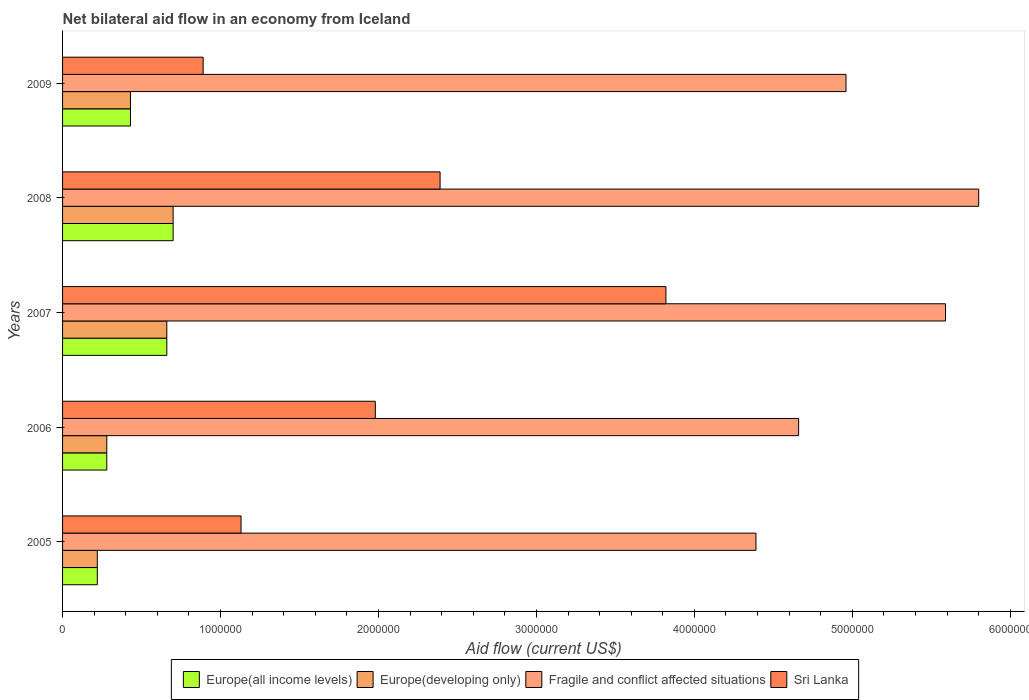How many different coloured bars are there?
Your answer should be compact. 4. How many groups of bars are there?
Offer a terse response. 5. Are the number of bars on each tick of the Y-axis equal?
Offer a terse response. Yes. How many bars are there on the 2nd tick from the top?
Your answer should be very brief. 4. What is the net bilateral aid flow in Europe(all income levels) in 2007?
Provide a short and direct response. 6.60e+05. Across all years, what is the maximum net bilateral aid flow in Fragile and conflict affected situations?
Keep it short and to the point. 5.80e+06. Across all years, what is the minimum net bilateral aid flow in Fragile and conflict affected situations?
Your answer should be very brief. 4.39e+06. What is the total net bilateral aid flow in Europe(all income levels) in the graph?
Keep it short and to the point. 2.29e+06. What is the difference between the net bilateral aid flow in Europe(developing only) in 2009 and the net bilateral aid flow in Fragile and conflict affected situations in 2007?
Provide a short and direct response. -5.16e+06. What is the average net bilateral aid flow in Sri Lanka per year?
Offer a very short reply. 2.04e+06. In the year 2005, what is the difference between the net bilateral aid flow in Sri Lanka and net bilateral aid flow in Europe(developing only)?
Provide a succinct answer. 9.10e+05. In how many years, is the net bilateral aid flow in Europe(all income levels) greater than 2800000 US$?
Provide a succinct answer. 0. What is the ratio of the net bilateral aid flow in Europe(all income levels) in 2005 to that in 2008?
Provide a short and direct response. 0.31. Is the net bilateral aid flow in Europe(developing only) in 2006 less than that in 2008?
Provide a short and direct response. Yes. Is the difference between the net bilateral aid flow in Sri Lanka in 2005 and 2008 greater than the difference between the net bilateral aid flow in Europe(developing only) in 2005 and 2008?
Offer a very short reply. No. What is the difference between the highest and the lowest net bilateral aid flow in Europe(all income levels)?
Give a very brief answer. 4.80e+05. In how many years, is the net bilateral aid flow in Europe(developing only) greater than the average net bilateral aid flow in Europe(developing only) taken over all years?
Your answer should be very brief. 2. Is the sum of the net bilateral aid flow in Europe(developing only) in 2008 and 2009 greater than the maximum net bilateral aid flow in Europe(all income levels) across all years?
Offer a terse response. Yes. What does the 1st bar from the top in 2008 represents?
Make the answer very short. Sri Lanka. What does the 4th bar from the bottom in 2008 represents?
Your answer should be compact. Sri Lanka. Is it the case that in every year, the sum of the net bilateral aid flow in Europe(all income levels) and net bilateral aid flow in Europe(developing only) is greater than the net bilateral aid flow in Fragile and conflict affected situations?
Offer a terse response. No. How many bars are there?
Offer a very short reply. 20. Are all the bars in the graph horizontal?
Give a very brief answer. Yes. How many years are there in the graph?
Offer a terse response. 5. What is the difference between two consecutive major ticks on the X-axis?
Offer a terse response. 1.00e+06. How many legend labels are there?
Offer a very short reply. 4. What is the title of the graph?
Offer a very short reply. Net bilateral aid flow in an economy from Iceland. Does "Libya" appear as one of the legend labels in the graph?
Give a very brief answer. No. What is the label or title of the Y-axis?
Offer a very short reply. Years. What is the Aid flow (current US$) in Europe(developing only) in 2005?
Make the answer very short. 2.20e+05. What is the Aid flow (current US$) in Fragile and conflict affected situations in 2005?
Ensure brevity in your answer.  4.39e+06. What is the Aid flow (current US$) in Sri Lanka in 2005?
Your response must be concise. 1.13e+06. What is the Aid flow (current US$) in Europe(all income levels) in 2006?
Your answer should be compact. 2.80e+05. What is the Aid flow (current US$) in Europe(developing only) in 2006?
Give a very brief answer. 2.80e+05. What is the Aid flow (current US$) in Fragile and conflict affected situations in 2006?
Provide a succinct answer. 4.66e+06. What is the Aid flow (current US$) in Sri Lanka in 2006?
Offer a very short reply. 1.98e+06. What is the Aid flow (current US$) in Europe(all income levels) in 2007?
Offer a terse response. 6.60e+05. What is the Aid flow (current US$) of Fragile and conflict affected situations in 2007?
Make the answer very short. 5.59e+06. What is the Aid flow (current US$) of Sri Lanka in 2007?
Give a very brief answer. 3.82e+06. What is the Aid flow (current US$) in Fragile and conflict affected situations in 2008?
Offer a terse response. 5.80e+06. What is the Aid flow (current US$) in Sri Lanka in 2008?
Your response must be concise. 2.39e+06. What is the Aid flow (current US$) of Europe(developing only) in 2009?
Give a very brief answer. 4.30e+05. What is the Aid flow (current US$) of Fragile and conflict affected situations in 2009?
Give a very brief answer. 4.96e+06. What is the Aid flow (current US$) of Sri Lanka in 2009?
Give a very brief answer. 8.90e+05. Across all years, what is the maximum Aid flow (current US$) of Fragile and conflict affected situations?
Your answer should be compact. 5.80e+06. Across all years, what is the maximum Aid flow (current US$) in Sri Lanka?
Your answer should be compact. 3.82e+06. Across all years, what is the minimum Aid flow (current US$) in Europe(all income levels)?
Offer a very short reply. 2.20e+05. Across all years, what is the minimum Aid flow (current US$) of Europe(developing only)?
Give a very brief answer. 2.20e+05. Across all years, what is the minimum Aid flow (current US$) in Fragile and conflict affected situations?
Offer a very short reply. 4.39e+06. Across all years, what is the minimum Aid flow (current US$) in Sri Lanka?
Ensure brevity in your answer.  8.90e+05. What is the total Aid flow (current US$) of Europe(all income levels) in the graph?
Ensure brevity in your answer.  2.29e+06. What is the total Aid flow (current US$) of Europe(developing only) in the graph?
Your response must be concise. 2.29e+06. What is the total Aid flow (current US$) in Fragile and conflict affected situations in the graph?
Offer a terse response. 2.54e+07. What is the total Aid flow (current US$) of Sri Lanka in the graph?
Provide a short and direct response. 1.02e+07. What is the difference between the Aid flow (current US$) in Sri Lanka in 2005 and that in 2006?
Give a very brief answer. -8.50e+05. What is the difference between the Aid flow (current US$) of Europe(all income levels) in 2005 and that in 2007?
Make the answer very short. -4.40e+05. What is the difference between the Aid flow (current US$) of Europe(developing only) in 2005 and that in 2007?
Your answer should be very brief. -4.40e+05. What is the difference between the Aid flow (current US$) of Fragile and conflict affected situations in 2005 and that in 2007?
Ensure brevity in your answer.  -1.20e+06. What is the difference between the Aid flow (current US$) of Sri Lanka in 2005 and that in 2007?
Offer a very short reply. -2.69e+06. What is the difference between the Aid flow (current US$) of Europe(all income levels) in 2005 and that in 2008?
Keep it short and to the point. -4.80e+05. What is the difference between the Aid flow (current US$) in Europe(developing only) in 2005 and that in 2008?
Offer a very short reply. -4.80e+05. What is the difference between the Aid flow (current US$) in Fragile and conflict affected situations in 2005 and that in 2008?
Ensure brevity in your answer.  -1.41e+06. What is the difference between the Aid flow (current US$) of Sri Lanka in 2005 and that in 2008?
Your answer should be very brief. -1.26e+06. What is the difference between the Aid flow (current US$) of Fragile and conflict affected situations in 2005 and that in 2009?
Offer a terse response. -5.70e+05. What is the difference between the Aid flow (current US$) in Sri Lanka in 2005 and that in 2009?
Offer a very short reply. 2.40e+05. What is the difference between the Aid flow (current US$) in Europe(all income levels) in 2006 and that in 2007?
Your response must be concise. -3.80e+05. What is the difference between the Aid flow (current US$) of Europe(developing only) in 2006 and that in 2007?
Offer a very short reply. -3.80e+05. What is the difference between the Aid flow (current US$) in Fragile and conflict affected situations in 2006 and that in 2007?
Ensure brevity in your answer.  -9.30e+05. What is the difference between the Aid flow (current US$) of Sri Lanka in 2006 and that in 2007?
Make the answer very short. -1.84e+06. What is the difference between the Aid flow (current US$) in Europe(all income levels) in 2006 and that in 2008?
Provide a short and direct response. -4.20e+05. What is the difference between the Aid flow (current US$) of Europe(developing only) in 2006 and that in 2008?
Ensure brevity in your answer.  -4.20e+05. What is the difference between the Aid flow (current US$) of Fragile and conflict affected situations in 2006 and that in 2008?
Your answer should be very brief. -1.14e+06. What is the difference between the Aid flow (current US$) of Sri Lanka in 2006 and that in 2008?
Offer a very short reply. -4.10e+05. What is the difference between the Aid flow (current US$) of Europe(developing only) in 2006 and that in 2009?
Your answer should be very brief. -1.50e+05. What is the difference between the Aid flow (current US$) of Sri Lanka in 2006 and that in 2009?
Make the answer very short. 1.09e+06. What is the difference between the Aid flow (current US$) in Europe(all income levels) in 2007 and that in 2008?
Provide a succinct answer. -4.00e+04. What is the difference between the Aid flow (current US$) of Europe(developing only) in 2007 and that in 2008?
Your answer should be very brief. -4.00e+04. What is the difference between the Aid flow (current US$) of Fragile and conflict affected situations in 2007 and that in 2008?
Provide a succinct answer. -2.10e+05. What is the difference between the Aid flow (current US$) in Sri Lanka in 2007 and that in 2008?
Offer a very short reply. 1.43e+06. What is the difference between the Aid flow (current US$) of Europe(all income levels) in 2007 and that in 2009?
Your answer should be compact. 2.30e+05. What is the difference between the Aid flow (current US$) in Fragile and conflict affected situations in 2007 and that in 2009?
Give a very brief answer. 6.30e+05. What is the difference between the Aid flow (current US$) of Sri Lanka in 2007 and that in 2009?
Provide a short and direct response. 2.93e+06. What is the difference between the Aid flow (current US$) of Europe(all income levels) in 2008 and that in 2009?
Offer a very short reply. 2.70e+05. What is the difference between the Aid flow (current US$) of Europe(developing only) in 2008 and that in 2009?
Your response must be concise. 2.70e+05. What is the difference between the Aid flow (current US$) in Fragile and conflict affected situations in 2008 and that in 2009?
Make the answer very short. 8.40e+05. What is the difference between the Aid flow (current US$) of Sri Lanka in 2008 and that in 2009?
Your response must be concise. 1.50e+06. What is the difference between the Aid flow (current US$) in Europe(all income levels) in 2005 and the Aid flow (current US$) in Fragile and conflict affected situations in 2006?
Ensure brevity in your answer.  -4.44e+06. What is the difference between the Aid flow (current US$) of Europe(all income levels) in 2005 and the Aid flow (current US$) of Sri Lanka in 2006?
Give a very brief answer. -1.76e+06. What is the difference between the Aid flow (current US$) in Europe(developing only) in 2005 and the Aid flow (current US$) in Fragile and conflict affected situations in 2006?
Offer a terse response. -4.44e+06. What is the difference between the Aid flow (current US$) of Europe(developing only) in 2005 and the Aid flow (current US$) of Sri Lanka in 2006?
Keep it short and to the point. -1.76e+06. What is the difference between the Aid flow (current US$) of Fragile and conflict affected situations in 2005 and the Aid flow (current US$) of Sri Lanka in 2006?
Ensure brevity in your answer.  2.41e+06. What is the difference between the Aid flow (current US$) of Europe(all income levels) in 2005 and the Aid flow (current US$) of Europe(developing only) in 2007?
Make the answer very short. -4.40e+05. What is the difference between the Aid flow (current US$) of Europe(all income levels) in 2005 and the Aid flow (current US$) of Fragile and conflict affected situations in 2007?
Your answer should be very brief. -5.37e+06. What is the difference between the Aid flow (current US$) in Europe(all income levels) in 2005 and the Aid flow (current US$) in Sri Lanka in 2007?
Offer a terse response. -3.60e+06. What is the difference between the Aid flow (current US$) of Europe(developing only) in 2005 and the Aid flow (current US$) of Fragile and conflict affected situations in 2007?
Give a very brief answer. -5.37e+06. What is the difference between the Aid flow (current US$) of Europe(developing only) in 2005 and the Aid flow (current US$) of Sri Lanka in 2007?
Keep it short and to the point. -3.60e+06. What is the difference between the Aid flow (current US$) in Fragile and conflict affected situations in 2005 and the Aid flow (current US$) in Sri Lanka in 2007?
Provide a short and direct response. 5.70e+05. What is the difference between the Aid flow (current US$) in Europe(all income levels) in 2005 and the Aid flow (current US$) in Europe(developing only) in 2008?
Offer a very short reply. -4.80e+05. What is the difference between the Aid flow (current US$) of Europe(all income levels) in 2005 and the Aid flow (current US$) of Fragile and conflict affected situations in 2008?
Keep it short and to the point. -5.58e+06. What is the difference between the Aid flow (current US$) in Europe(all income levels) in 2005 and the Aid flow (current US$) in Sri Lanka in 2008?
Keep it short and to the point. -2.17e+06. What is the difference between the Aid flow (current US$) of Europe(developing only) in 2005 and the Aid flow (current US$) of Fragile and conflict affected situations in 2008?
Your answer should be compact. -5.58e+06. What is the difference between the Aid flow (current US$) in Europe(developing only) in 2005 and the Aid flow (current US$) in Sri Lanka in 2008?
Offer a very short reply. -2.17e+06. What is the difference between the Aid flow (current US$) in Fragile and conflict affected situations in 2005 and the Aid flow (current US$) in Sri Lanka in 2008?
Give a very brief answer. 2.00e+06. What is the difference between the Aid flow (current US$) of Europe(all income levels) in 2005 and the Aid flow (current US$) of Fragile and conflict affected situations in 2009?
Offer a terse response. -4.74e+06. What is the difference between the Aid flow (current US$) of Europe(all income levels) in 2005 and the Aid flow (current US$) of Sri Lanka in 2009?
Keep it short and to the point. -6.70e+05. What is the difference between the Aid flow (current US$) of Europe(developing only) in 2005 and the Aid flow (current US$) of Fragile and conflict affected situations in 2009?
Give a very brief answer. -4.74e+06. What is the difference between the Aid flow (current US$) of Europe(developing only) in 2005 and the Aid flow (current US$) of Sri Lanka in 2009?
Your answer should be very brief. -6.70e+05. What is the difference between the Aid flow (current US$) in Fragile and conflict affected situations in 2005 and the Aid flow (current US$) in Sri Lanka in 2009?
Keep it short and to the point. 3.50e+06. What is the difference between the Aid flow (current US$) in Europe(all income levels) in 2006 and the Aid flow (current US$) in Europe(developing only) in 2007?
Ensure brevity in your answer.  -3.80e+05. What is the difference between the Aid flow (current US$) in Europe(all income levels) in 2006 and the Aid flow (current US$) in Fragile and conflict affected situations in 2007?
Offer a very short reply. -5.31e+06. What is the difference between the Aid flow (current US$) in Europe(all income levels) in 2006 and the Aid flow (current US$) in Sri Lanka in 2007?
Your answer should be compact. -3.54e+06. What is the difference between the Aid flow (current US$) of Europe(developing only) in 2006 and the Aid flow (current US$) of Fragile and conflict affected situations in 2007?
Give a very brief answer. -5.31e+06. What is the difference between the Aid flow (current US$) of Europe(developing only) in 2006 and the Aid flow (current US$) of Sri Lanka in 2007?
Provide a short and direct response. -3.54e+06. What is the difference between the Aid flow (current US$) of Fragile and conflict affected situations in 2006 and the Aid flow (current US$) of Sri Lanka in 2007?
Keep it short and to the point. 8.40e+05. What is the difference between the Aid flow (current US$) in Europe(all income levels) in 2006 and the Aid flow (current US$) in Europe(developing only) in 2008?
Your answer should be very brief. -4.20e+05. What is the difference between the Aid flow (current US$) in Europe(all income levels) in 2006 and the Aid flow (current US$) in Fragile and conflict affected situations in 2008?
Your answer should be compact. -5.52e+06. What is the difference between the Aid flow (current US$) in Europe(all income levels) in 2006 and the Aid flow (current US$) in Sri Lanka in 2008?
Make the answer very short. -2.11e+06. What is the difference between the Aid flow (current US$) in Europe(developing only) in 2006 and the Aid flow (current US$) in Fragile and conflict affected situations in 2008?
Give a very brief answer. -5.52e+06. What is the difference between the Aid flow (current US$) of Europe(developing only) in 2006 and the Aid flow (current US$) of Sri Lanka in 2008?
Give a very brief answer. -2.11e+06. What is the difference between the Aid flow (current US$) of Fragile and conflict affected situations in 2006 and the Aid flow (current US$) of Sri Lanka in 2008?
Make the answer very short. 2.27e+06. What is the difference between the Aid flow (current US$) in Europe(all income levels) in 2006 and the Aid flow (current US$) in Fragile and conflict affected situations in 2009?
Provide a short and direct response. -4.68e+06. What is the difference between the Aid flow (current US$) of Europe(all income levels) in 2006 and the Aid flow (current US$) of Sri Lanka in 2009?
Your answer should be very brief. -6.10e+05. What is the difference between the Aid flow (current US$) in Europe(developing only) in 2006 and the Aid flow (current US$) in Fragile and conflict affected situations in 2009?
Give a very brief answer. -4.68e+06. What is the difference between the Aid flow (current US$) in Europe(developing only) in 2006 and the Aid flow (current US$) in Sri Lanka in 2009?
Make the answer very short. -6.10e+05. What is the difference between the Aid flow (current US$) of Fragile and conflict affected situations in 2006 and the Aid flow (current US$) of Sri Lanka in 2009?
Ensure brevity in your answer.  3.77e+06. What is the difference between the Aid flow (current US$) of Europe(all income levels) in 2007 and the Aid flow (current US$) of Europe(developing only) in 2008?
Offer a very short reply. -4.00e+04. What is the difference between the Aid flow (current US$) in Europe(all income levels) in 2007 and the Aid flow (current US$) in Fragile and conflict affected situations in 2008?
Your answer should be compact. -5.14e+06. What is the difference between the Aid flow (current US$) of Europe(all income levels) in 2007 and the Aid flow (current US$) of Sri Lanka in 2008?
Make the answer very short. -1.73e+06. What is the difference between the Aid flow (current US$) of Europe(developing only) in 2007 and the Aid flow (current US$) of Fragile and conflict affected situations in 2008?
Offer a terse response. -5.14e+06. What is the difference between the Aid flow (current US$) in Europe(developing only) in 2007 and the Aid flow (current US$) in Sri Lanka in 2008?
Your answer should be compact. -1.73e+06. What is the difference between the Aid flow (current US$) in Fragile and conflict affected situations in 2007 and the Aid flow (current US$) in Sri Lanka in 2008?
Make the answer very short. 3.20e+06. What is the difference between the Aid flow (current US$) of Europe(all income levels) in 2007 and the Aid flow (current US$) of Europe(developing only) in 2009?
Ensure brevity in your answer.  2.30e+05. What is the difference between the Aid flow (current US$) of Europe(all income levels) in 2007 and the Aid flow (current US$) of Fragile and conflict affected situations in 2009?
Your response must be concise. -4.30e+06. What is the difference between the Aid flow (current US$) in Europe(developing only) in 2007 and the Aid flow (current US$) in Fragile and conflict affected situations in 2009?
Provide a short and direct response. -4.30e+06. What is the difference between the Aid flow (current US$) in Fragile and conflict affected situations in 2007 and the Aid flow (current US$) in Sri Lanka in 2009?
Your answer should be compact. 4.70e+06. What is the difference between the Aid flow (current US$) of Europe(all income levels) in 2008 and the Aid flow (current US$) of Fragile and conflict affected situations in 2009?
Provide a succinct answer. -4.26e+06. What is the difference between the Aid flow (current US$) of Europe(all income levels) in 2008 and the Aid flow (current US$) of Sri Lanka in 2009?
Offer a very short reply. -1.90e+05. What is the difference between the Aid flow (current US$) in Europe(developing only) in 2008 and the Aid flow (current US$) in Fragile and conflict affected situations in 2009?
Your answer should be very brief. -4.26e+06. What is the difference between the Aid flow (current US$) of Fragile and conflict affected situations in 2008 and the Aid flow (current US$) of Sri Lanka in 2009?
Provide a short and direct response. 4.91e+06. What is the average Aid flow (current US$) in Europe(all income levels) per year?
Ensure brevity in your answer.  4.58e+05. What is the average Aid flow (current US$) in Europe(developing only) per year?
Provide a succinct answer. 4.58e+05. What is the average Aid flow (current US$) in Fragile and conflict affected situations per year?
Ensure brevity in your answer.  5.08e+06. What is the average Aid flow (current US$) in Sri Lanka per year?
Offer a terse response. 2.04e+06. In the year 2005, what is the difference between the Aid flow (current US$) in Europe(all income levels) and Aid flow (current US$) in Fragile and conflict affected situations?
Make the answer very short. -4.17e+06. In the year 2005, what is the difference between the Aid flow (current US$) in Europe(all income levels) and Aid flow (current US$) in Sri Lanka?
Your response must be concise. -9.10e+05. In the year 2005, what is the difference between the Aid flow (current US$) in Europe(developing only) and Aid flow (current US$) in Fragile and conflict affected situations?
Make the answer very short. -4.17e+06. In the year 2005, what is the difference between the Aid flow (current US$) in Europe(developing only) and Aid flow (current US$) in Sri Lanka?
Keep it short and to the point. -9.10e+05. In the year 2005, what is the difference between the Aid flow (current US$) in Fragile and conflict affected situations and Aid flow (current US$) in Sri Lanka?
Offer a terse response. 3.26e+06. In the year 2006, what is the difference between the Aid flow (current US$) in Europe(all income levels) and Aid flow (current US$) in Europe(developing only)?
Make the answer very short. 0. In the year 2006, what is the difference between the Aid flow (current US$) in Europe(all income levels) and Aid flow (current US$) in Fragile and conflict affected situations?
Your response must be concise. -4.38e+06. In the year 2006, what is the difference between the Aid flow (current US$) of Europe(all income levels) and Aid flow (current US$) of Sri Lanka?
Keep it short and to the point. -1.70e+06. In the year 2006, what is the difference between the Aid flow (current US$) of Europe(developing only) and Aid flow (current US$) of Fragile and conflict affected situations?
Provide a succinct answer. -4.38e+06. In the year 2006, what is the difference between the Aid flow (current US$) in Europe(developing only) and Aid flow (current US$) in Sri Lanka?
Ensure brevity in your answer.  -1.70e+06. In the year 2006, what is the difference between the Aid flow (current US$) of Fragile and conflict affected situations and Aid flow (current US$) of Sri Lanka?
Keep it short and to the point. 2.68e+06. In the year 2007, what is the difference between the Aid flow (current US$) of Europe(all income levels) and Aid flow (current US$) of Fragile and conflict affected situations?
Provide a succinct answer. -4.93e+06. In the year 2007, what is the difference between the Aid flow (current US$) in Europe(all income levels) and Aid flow (current US$) in Sri Lanka?
Keep it short and to the point. -3.16e+06. In the year 2007, what is the difference between the Aid flow (current US$) in Europe(developing only) and Aid flow (current US$) in Fragile and conflict affected situations?
Make the answer very short. -4.93e+06. In the year 2007, what is the difference between the Aid flow (current US$) in Europe(developing only) and Aid flow (current US$) in Sri Lanka?
Ensure brevity in your answer.  -3.16e+06. In the year 2007, what is the difference between the Aid flow (current US$) in Fragile and conflict affected situations and Aid flow (current US$) in Sri Lanka?
Your response must be concise. 1.77e+06. In the year 2008, what is the difference between the Aid flow (current US$) in Europe(all income levels) and Aid flow (current US$) in Europe(developing only)?
Provide a short and direct response. 0. In the year 2008, what is the difference between the Aid flow (current US$) of Europe(all income levels) and Aid flow (current US$) of Fragile and conflict affected situations?
Offer a terse response. -5.10e+06. In the year 2008, what is the difference between the Aid flow (current US$) of Europe(all income levels) and Aid flow (current US$) of Sri Lanka?
Offer a terse response. -1.69e+06. In the year 2008, what is the difference between the Aid flow (current US$) of Europe(developing only) and Aid flow (current US$) of Fragile and conflict affected situations?
Offer a terse response. -5.10e+06. In the year 2008, what is the difference between the Aid flow (current US$) in Europe(developing only) and Aid flow (current US$) in Sri Lanka?
Give a very brief answer. -1.69e+06. In the year 2008, what is the difference between the Aid flow (current US$) in Fragile and conflict affected situations and Aid flow (current US$) in Sri Lanka?
Your answer should be compact. 3.41e+06. In the year 2009, what is the difference between the Aid flow (current US$) of Europe(all income levels) and Aid flow (current US$) of Fragile and conflict affected situations?
Make the answer very short. -4.53e+06. In the year 2009, what is the difference between the Aid flow (current US$) of Europe(all income levels) and Aid flow (current US$) of Sri Lanka?
Your answer should be very brief. -4.60e+05. In the year 2009, what is the difference between the Aid flow (current US$) of Europe(developing only) and Aid flow (current US$) of Fragile and conflict affected situations?
Ensure brevity in your answer.  -4.53e+06. In the year 2009, what is the difference between the Aid flow (current US$) in Europe(developing only) and Aid flow (current US$) in Sri Lanka?
Provide a succinct answer. -4.60e+05. In the year 2009, what is the difference between the Aid flow (current US$) of Fragile and conflict affected situations and Aid flow (current US$) of Sri Lanka?
Make the answer very short. 4.07e+06. What is the ratio of the Aid flow (current US$) of Europe(all income levels) in 2005 to that in 2006?
Offer a terse response. 0.79. What is the ratio of the Aid flow (current US$) of Europe(developing only) in 2005 to that in 2006?
Make the answer very short. 0.79. What is the ratio of the Aid flow (current US$) of Fragile and conflict affected situations in 2005 to that in 2006?
Your answer should be compact. 0.94. What is the ratio of the Aid flow (current US$) in Sri Lanka in 2005 to that in 2006?
Provide a succinct answer. 0.57. What is the ratio of the Aid flow (current US$) in Fragile and conflict affected situations in 2005 to that in 2007?
Provide a succinct answer. 0.79. What is the ratio of the Aid flow (current US$) of Sri Lanka in 2005 to that in 2007?
Offer a terse response. 0.3. What is the ratio of the Aid flow (current US$) in Europe(all income levels) in 2005 to that in 2008?
Give a very brief answer. 0.31. What is the ratio of the Aid flow (current US$) in Europe(developing only) in 2005 to that in 2008?
Make the answer very short. 0.31. What is the ratio of the Aid flow (current US$) in Fragile and conflict affected situations in 2005 to that in 2008?
Provide a succinct answer. 0.76. What is the ratio of the Aid flow (current US$) of Sri Lanka in 2005 to that in 2008?
Offer a very short reply. 0.47. What is the ratio of the Aid flow (current US$) of Europe(all income levels) in 2005 to that in 2009?
Provide a succinct answer. 0.51. What is the ratio of the Aid flow (current US$) of Europe(developing only) in 2005 to that in 2009?
Provide a short and direct response. 0.51. What is the ratio of the Aid flow (current US$) in Fragile and conflict affected situations in 2005 to that in 2009?
Offer a terse response. 0.89. What is the ratio of the Aid flow (current US$) in Sri Lanka in 2005 to that in 2009?
Your answer should be very brief. 1.27. What is the ratio of the Aid flow (current US$) of Europe(all income levels) in 2006 to that in 2007?
Make the answer very short. 0.42. What is the ratio of the Aid flow (current US$) of Europe(developing only) in 2006 to that in 2007?
Provide a succinct answer. 0.42. What is the ratio of the Aid flow (current US$) of Fragile and conflict affected situations in 2006 to that in 2007?
Ensure brevity in your answer.  0.83. What is the ratio of the Aid flow (current US$) in Sri Lanka in 2006 to that in 2007?
Provide a short and direct response. 0.52. What is the ratio of the Aid flow (current US$) of Europe(all income levels) in 2006 to that in 2008?
Ensure brevity in your answer.  0.4. What is the ratio of the Aid flow (current US$) in Fragile and conflict affected situations in 2006 to that in 2008?
Ensure brevity in your answer.  0.8. What is the ratio of the Aid flow (current US$) in Sri Lanka in 2006 to that in 2008?
Ensure brevity in your answer.  0.83. What is the ratio of the Aid flow (current US$) in Europe(all income levels) in 2006 to that in 2009?
Keep it short and to the point. 0.65. What is the ratio of the Aid flow (current US$) of Europe(developing only) in 2006 to that in 2009?
Offer a very short reply. 0.65. What is the ratio of the Aid flow (current US$) of Fragile and conflict affected situations in 2006 to that in 2009?
Provide a short and direct response. 0.94. What is the ratio of the Aid flow (current US$) in Sri Lanka in 2006 to that in 2009?
Keep it short and to the point. 2.22. What is the ratio of the Aid flow (current US$) of Europe(all income levels) in 2007 to that in 2008?
Your answer should be very brief. 0.94. What is the ratio of the Aid flow (current US$) of Europe(developing only) in 2007 to that in 2008?
Provide a short and direct response. 0.94. What is the ratio of the Aid flow (current US$) in Fragile and conflict affected situations in 2007 to that in 2008?
Your answer should be very brief. 0.96. What is the ratio of the Aid flow (current US$) in Sri Lanka in 2007 to that in 2008?
Provide a succinct answer. 1.6. What is the ratio of the Aid flow (current US$) in Europe(all income levels) in 2007 to that in 2009?
Make the answer very short. 1.53. What is the ratio of the Aid flow (current US$) of Europe(developing only) in 2007 to that in 2009?
Your response must be concise. 1.53. What is the ratio of the Aid flow (current US$) in Fragile and conflict affected situations in 2007 to that in 2009?
Your answer should be very brief. 1.13. What is the ratio of the Aid flow (current US$) in Sri Lanka in 2007 to that in 2009?
Your answer should be compact. 4.29. What is the ratio of the Aid flow (current US$) in Europe(all income levels) in 2008 to that in 2009?
Provide a succinct answer. 1.63. What is the ratio of the Aid flow (current US$) in Europe(developing only) in 2008 to that in 2009?
Provide a succinct answer. 1.63. What is the ratio of the Aid flow (current US$) in Fragile and conflict affected situations in 2008 to that in 2009?
Make the answer very short. 1.17. What is the ratio of the Aid flow (current US$) of Sri Lanka in 2008 to that in 2009?
Give a very brief answer. 2.69. What is the difference between the highest and the second highest Aid flow (current US$) in Europe(all income levels)?
Keep it short and to the point. 4.00e+04. What is the difference between the highest and the second highest Aid flow (current US$) of Europe(developing only)?
Keep it short and to the point. 4.00e+04. What is the difference between the highest and the second highest Aid flow (current US$) of Sri Lanka?
Make the answer very short. 1.43e+06. What is the difference between the highest and the lowest Aid flow (current US$) of Europe(all income levels)?
Your response must be concise. 4.80e+05. What is the difference between the highest and the lowest Aid flow (current US$) of Fragile and conflict affected situations?
Your answer should be very brief. 1.41e+06. What is the difference between the highest and the lowest Aid flow (current US$) of Sri Lanka?
Your answer should be compact. 2.93e+06. 